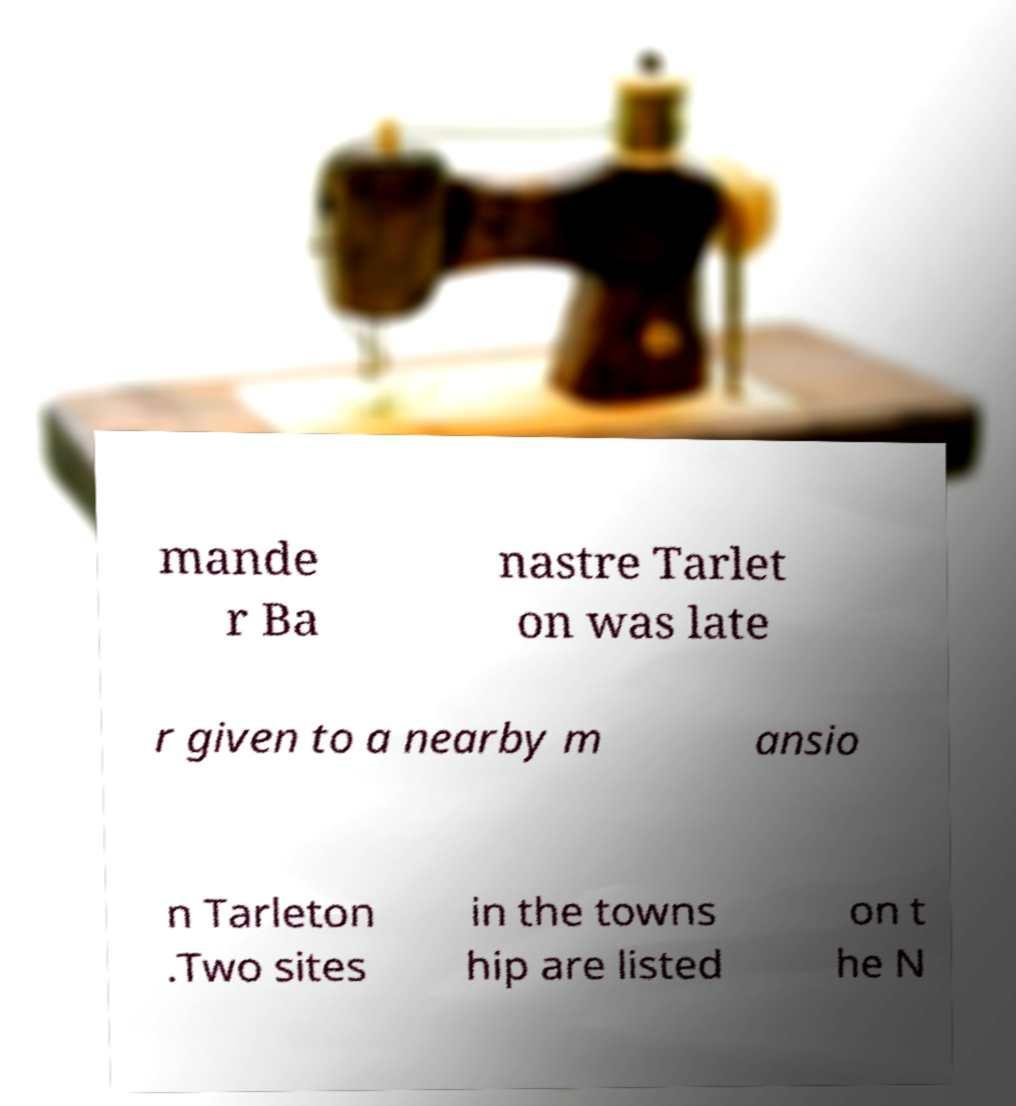What messages or text are displayed in this image? I need them in a readable, typed format. mande r Ba nastre Tarlet on was late r given to a nearby m ansio n Tarleton .Two sites in the towns hip are listed on t he N 